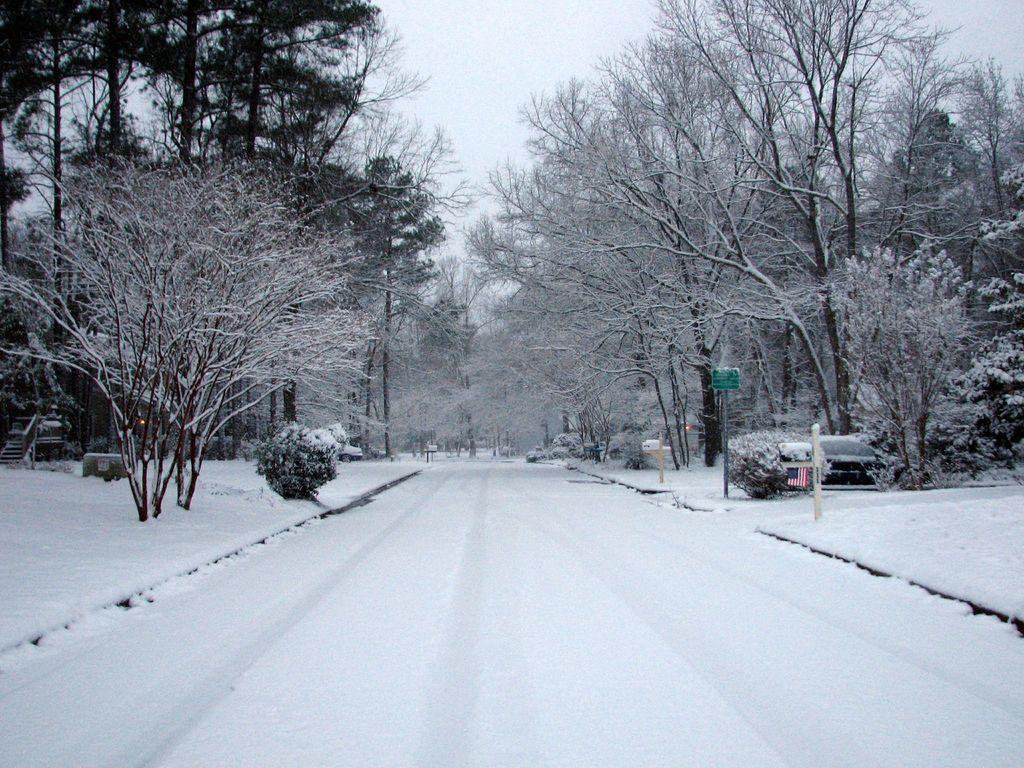How would you summarize this image in a sentence or two? In front of the image there is empty road, on the either side of the road there are trees and there are cars parked. 